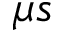<formula> <loc_0><loc_0><loc_500><loc_500>{ \mu } s</formula> 